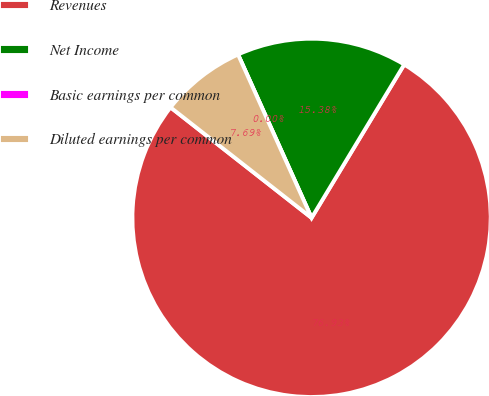<chart> <loc_0><loc_0><loc_500><loc_500><pie_chart><fcel>Revenues<fcel>Net Income<fcel>Basic earnings per common<fcel>Diluted earnings per common<nl><fcel>76.92%<fcel>15.38%<fcel>0.0%<fcel>7.69%<nl></chart> 